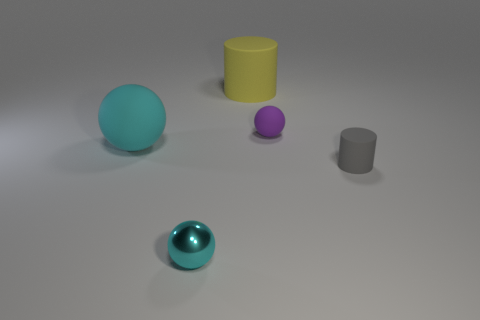The sphere that is the same size as the cyan metal object is what color?
Provide a short and direct response. Purple. Is there a yellow rubber object of the same shape as the tiny metal thing?
Your response must be concise. No. There is a cylinder that is in front of the rubber ball that is in front of the tiny rubber thing behind the large rubber sphere; what color is it?
Offer a terse response. Gray. What number of metallic objects are either tiny purple spheres or tiny green things?
Offer a terse response. 0. Are there more large yellow objects in front of the cyan metal sphere than purple matte objects on the right side of the gray matte cylinder?
Keep it short and to the point. No. How many other objects are there of the same size as the cyan rubber thing?
Keep it short and to the point. 1. There is a gray cylinder to the right of the cylinder that is behind the large rubber sphere; what size is it?
Keep it short and to the point. Small. How many large objects are purple spheres or metal things?
Ensure brevity in your answer.  0. There is a sphere right of the cyan metallic sphere that is to the left of the cylinder in front of the small purple ball; how big is it?
Keep it short and to the point. Small. Are there any other things that are the same color as the small matte cylinder?
Provide a short and direct response. No. 